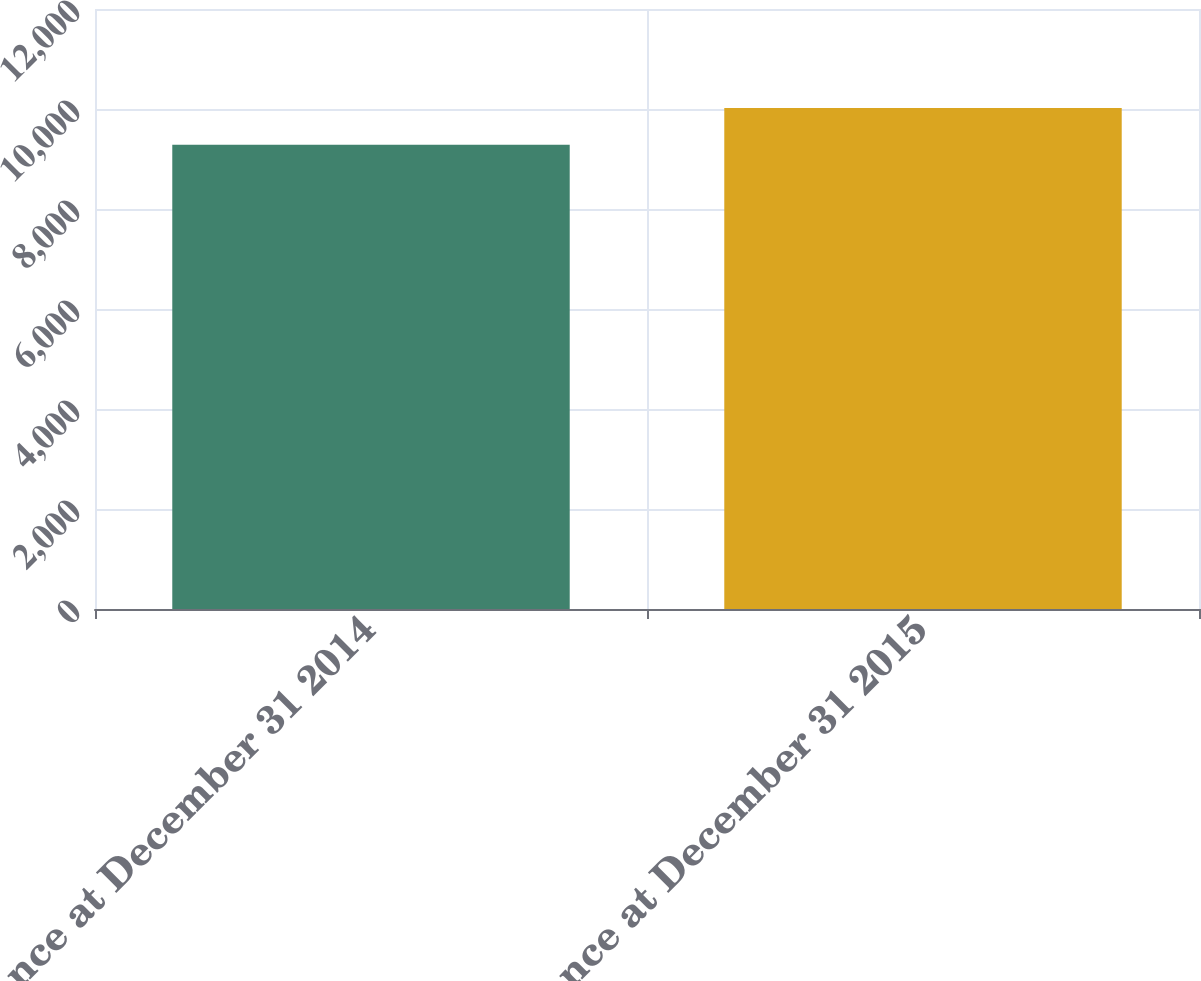Convert chart to OTSL. <chart><loc_0><loc_0><loc_500><loc_500><bar_chart><fcel>Balance at December 31 2014<fcel>Balance at December 31 2015<nl><fcel>9284<fcel>10019<nl></chart> 